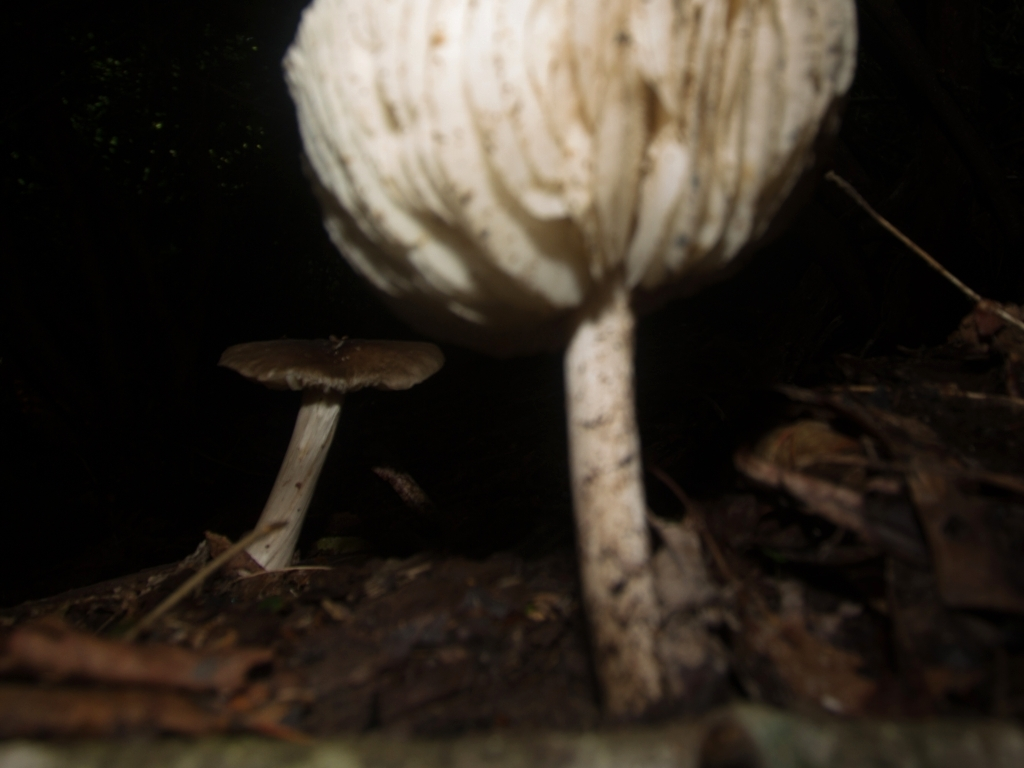What type of mushrooms are these, and are they edible? Without a crystal-clear image or a view of identifying features such as gills or the stem, it's difficult to definitively determine the species of these mushrooms, and therefore it is impossible to assess their edibility. Identifying mushrooms with precision typically requires expert knowledge and examination of several characteristics, and it is not recommended to consume wild mushrooms without proper identification due to the risk of poisoning. 